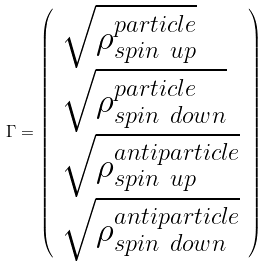Convert formula to latex. <formula><loc_0><loc_0><loc_500><loc_500>\Gamma = \left ( \begin{array} { l } \sqrt { \rho ^ { p a r t i c l e } _ { s p i n \ u p } } \\ \sqrt { \rho ^ { p a r t i c l e } _ { s p i n \ d o w n } } \\ \sqrt { \rho ^ { a n t i p a r t i c l e } _ { s p i n \ u p } } \\ \sqrt { \rho ^ { a n t i p a r t i c l e } _ { s p i n \ d o w n } } \\ \end{array} \right )</formula> 